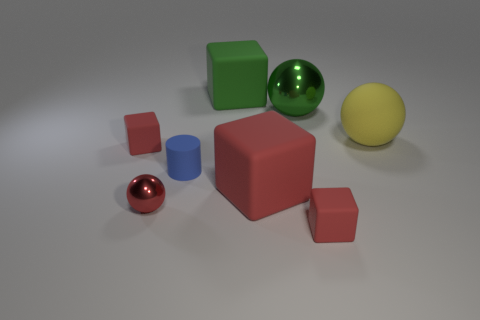How many objects are there in total? There are a total of seven objects in the image, including different shapes like spheres, cubes, and a cylinder. 